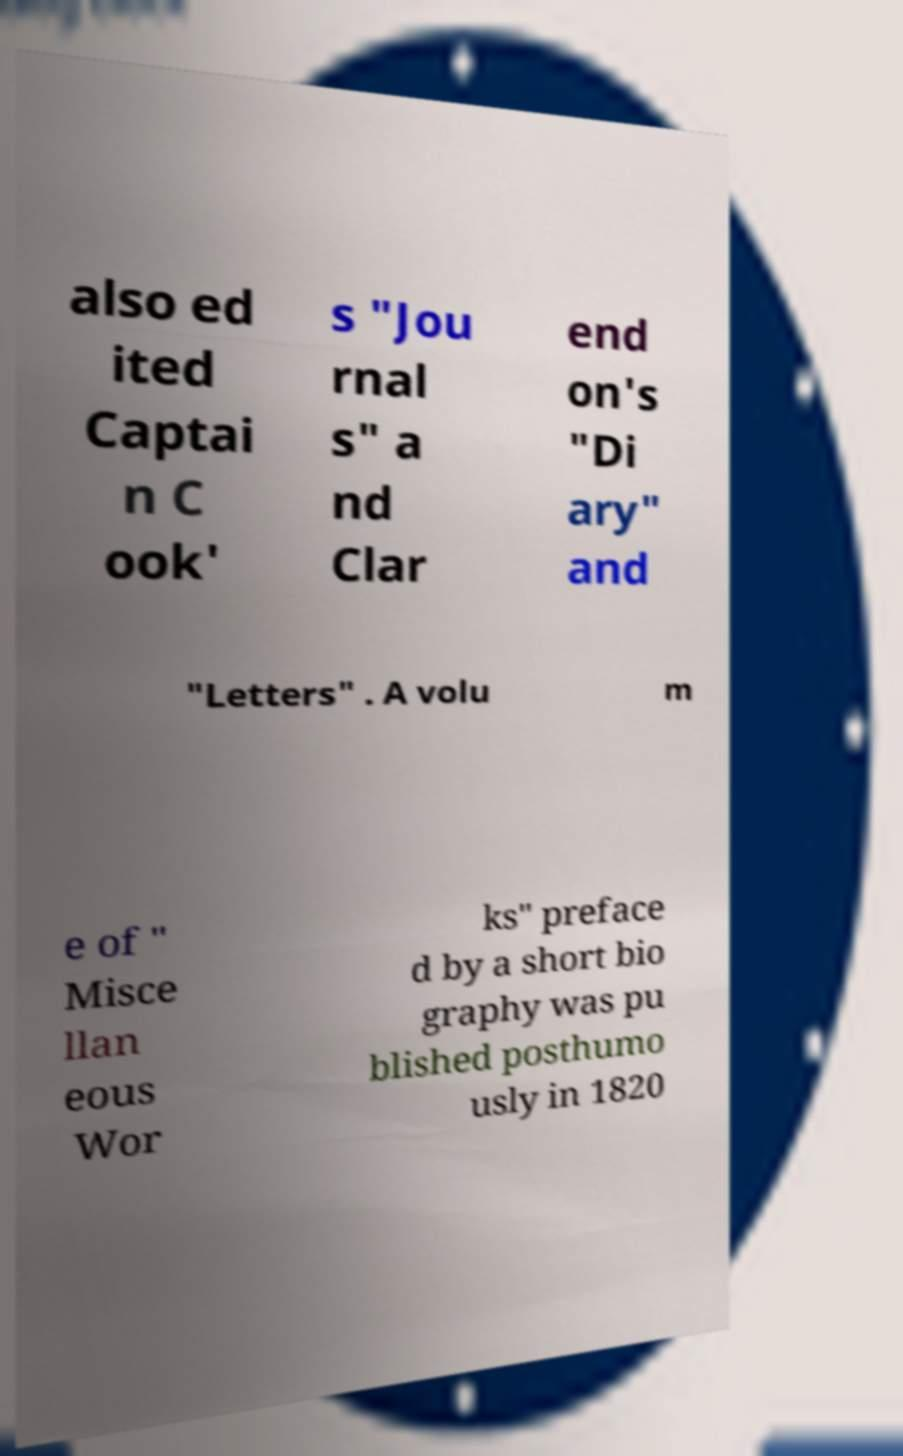Please identify and transcribe the text found in this image. also ed ited Captai n C ook' s "Jou rnal s" a nd Clar end on's "Di ary" and "Letters" . A volu m e of " Misce llan eous Wor ks" preface d by a short bio graphy was pu blished posthumo usly in 1820 